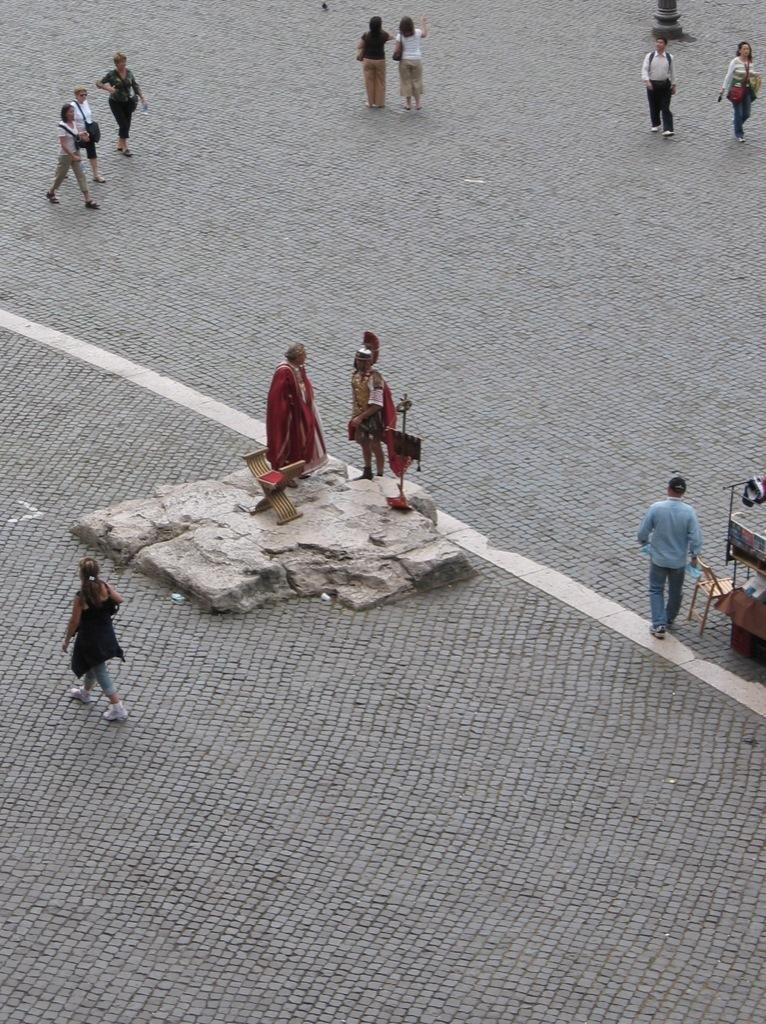What are the people in the image doing? The people in the image are walking. Are the people walking in the same direction? No, the people are walking from different directions. What is in the middle of the image? There is a rock in the middle of the image. Are there any people on the rock? Yes, two people are standing on the rock. Can you see any snakes biting people in the image? No, there are no snakes or bites visible in the image. 